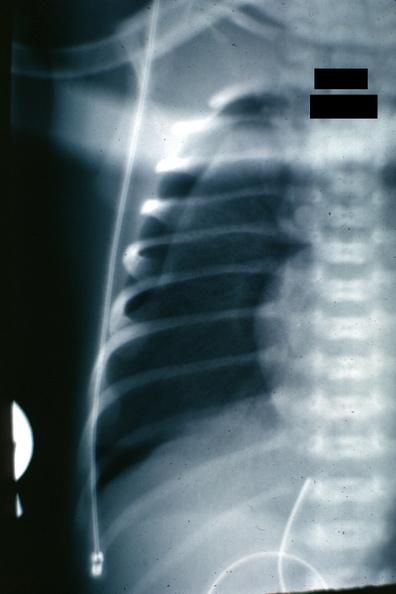does this image show x-ray close-up to show collapsed lung very easily seen?
Answer the question using a single word or phrase. Yes 